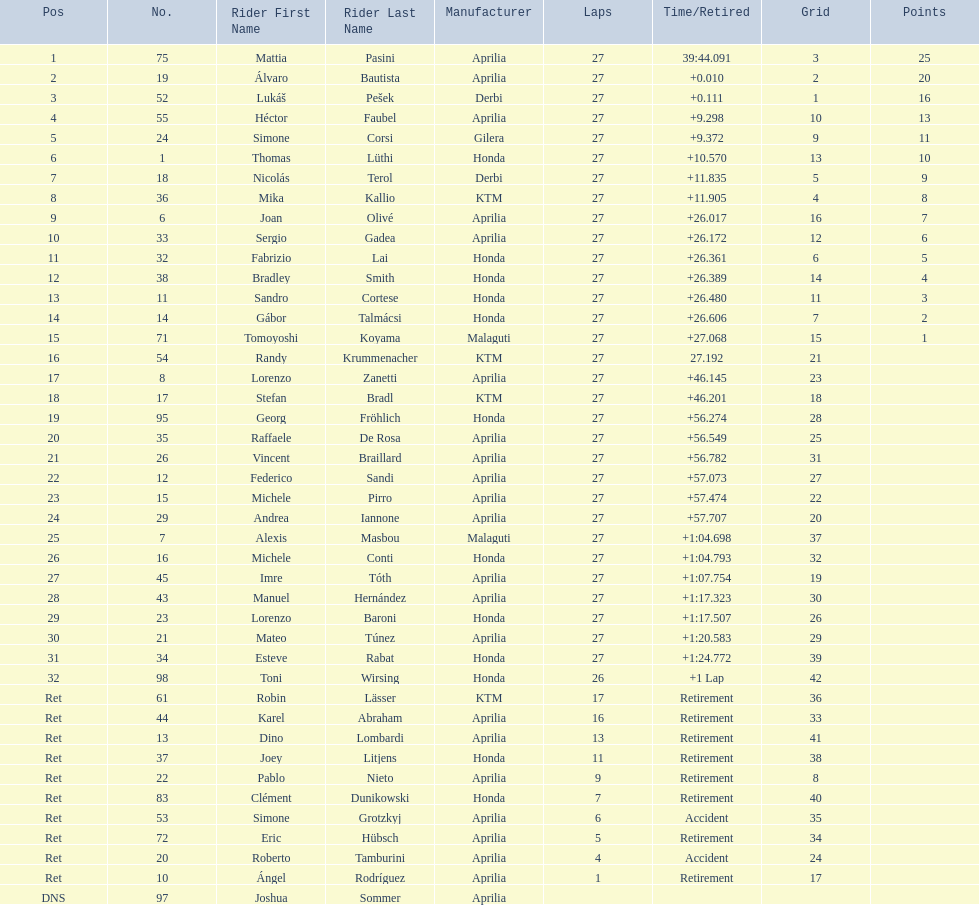How many german racers finished the race? 4. 